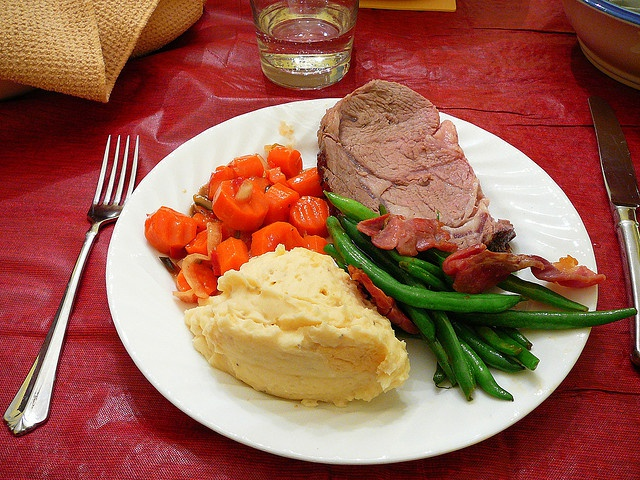Describe the objects in this image and their specific colors. I can see dining table in brown, maroon, white, and black tones, carrot in tan, red, brown, and orange tones, cup in tan, brown, and maroon tones, fork in tan, white, maroon, black, and darkgray tones, and knife in tan, maroon, black, darkgray, and lightgray tones in this image. 